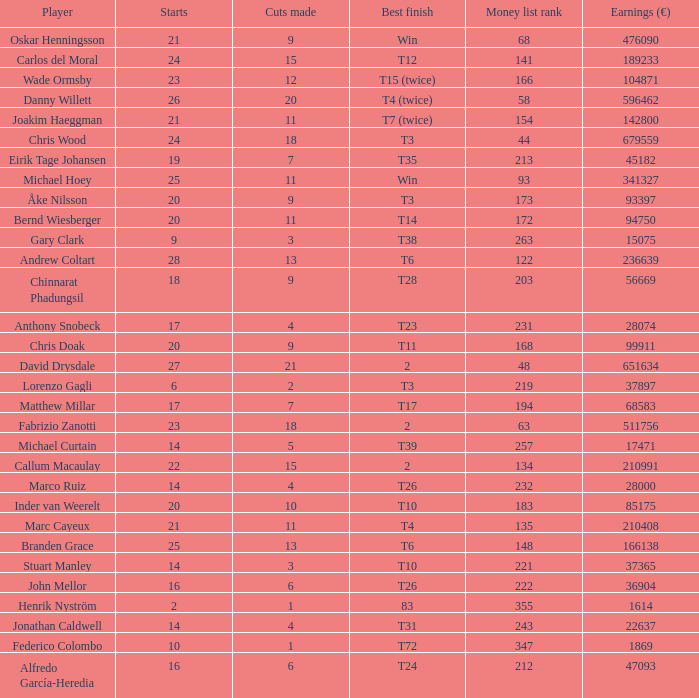Which player made exactly 26 starts? Danny Willett. 